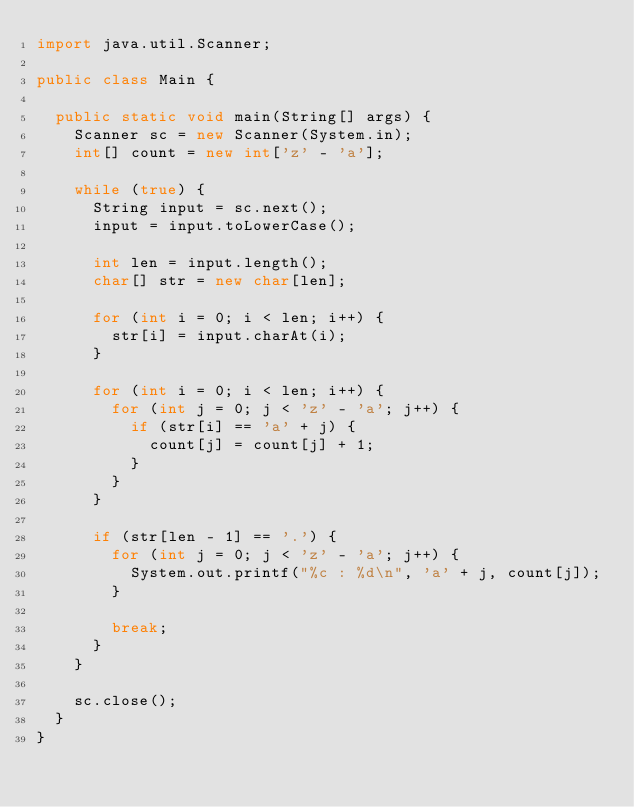Convert code to text. <code><loc_0><loc_0><loc_500><loc_500><_Java_>import java.util.Scanner;

public class Main {

	public static void main(String[] args) {
		Scanner sc = new Scanner(System.in);
		int[] count = new int['z' - 'a'];

		while (true) {
			String input = sc.next();
			input = input.toLowerCase();

			int len = input.length();
			char[] str = new char[len];

			for (int i = 0; i < len; i++) {
				str[i] = input.charAt(i);
			}

			for (int i = 0; i < len; i++) {
				for (int j = 0; j < 'z' - 'a'; j++) {
					if (str[i] == 'a' + j) {
						count[j] = count[j] + 1;
					}
				}
			}

			if (str[len - 1] == '.') {
				for (int j = 0; j < 'z' - 'a'; j++) {
					System.out.printf("%c : %d\n", 'a' + j, count[j]);
				}

				break;
			}
		}

		sc.close();
	}
}</code> 